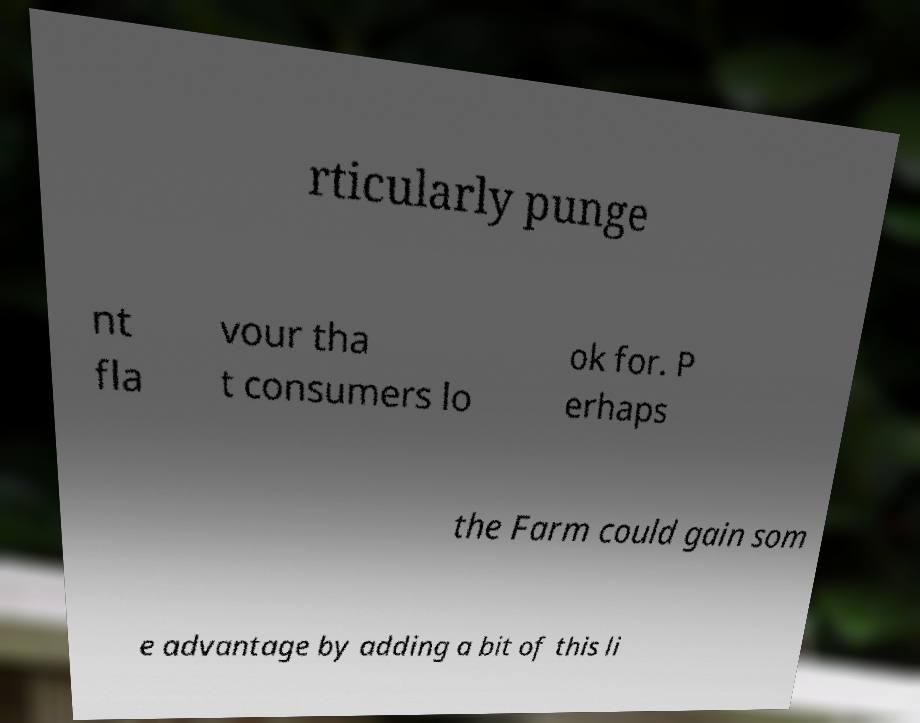Please read and relay the text visible in this image. What does it say? rticularly punge nt fla vour tha t consumers lo ok for. P erhaps the Farm could gain som e advantage by adding a bit of this li 